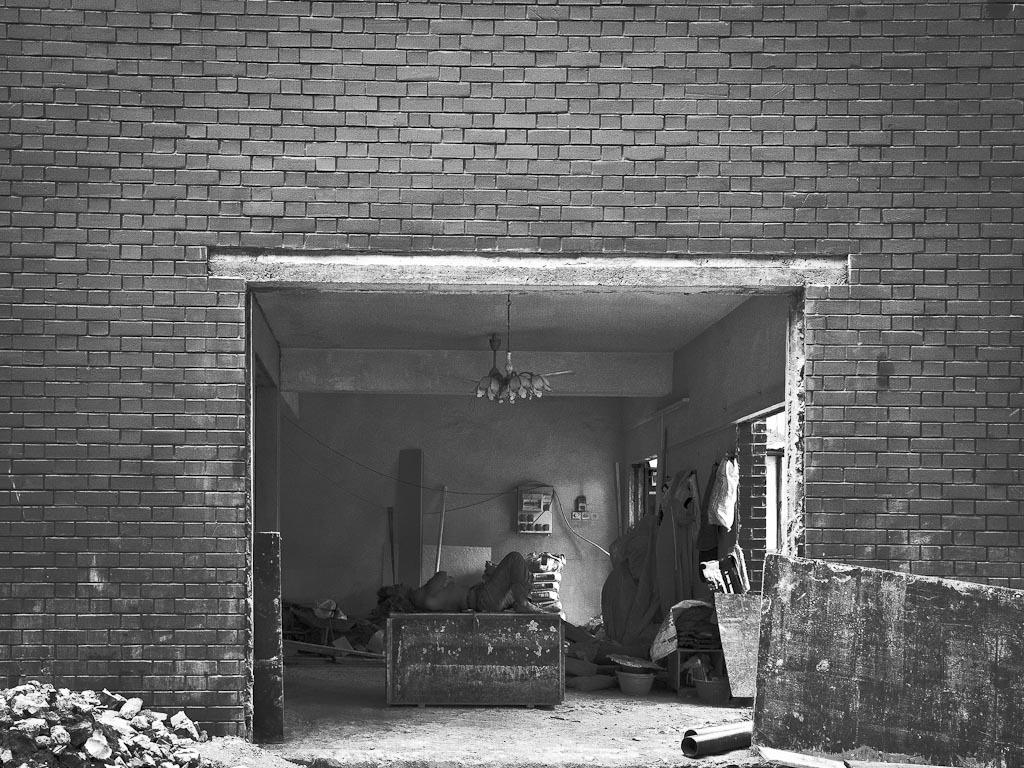What is the color scheme of the image? The image is in black and white. What can be seen on one side of the image? There is a wall in the image. What is the position of the person in the image? There is a person lying down in the image. What is visible beneath the person and wall? The ground is visible in the image. Can you describe any other elements in the image? There are many unspecified things in the image. What type of basin is being polished in the image? There is no basin or polishing activity present in the image. What is the person using to polish the basin in the image? There is no basin or polishing activity present in the image, so it is not possible to determine what the person might be using. 